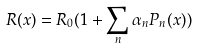<formula> <loc_0><loc_0><loc_500><loc_500>R ( x ) = R _ { 0 } ( 1 + \sum _ { n } \alpha _ { n } P _ { n } ( x ) )</formula> 